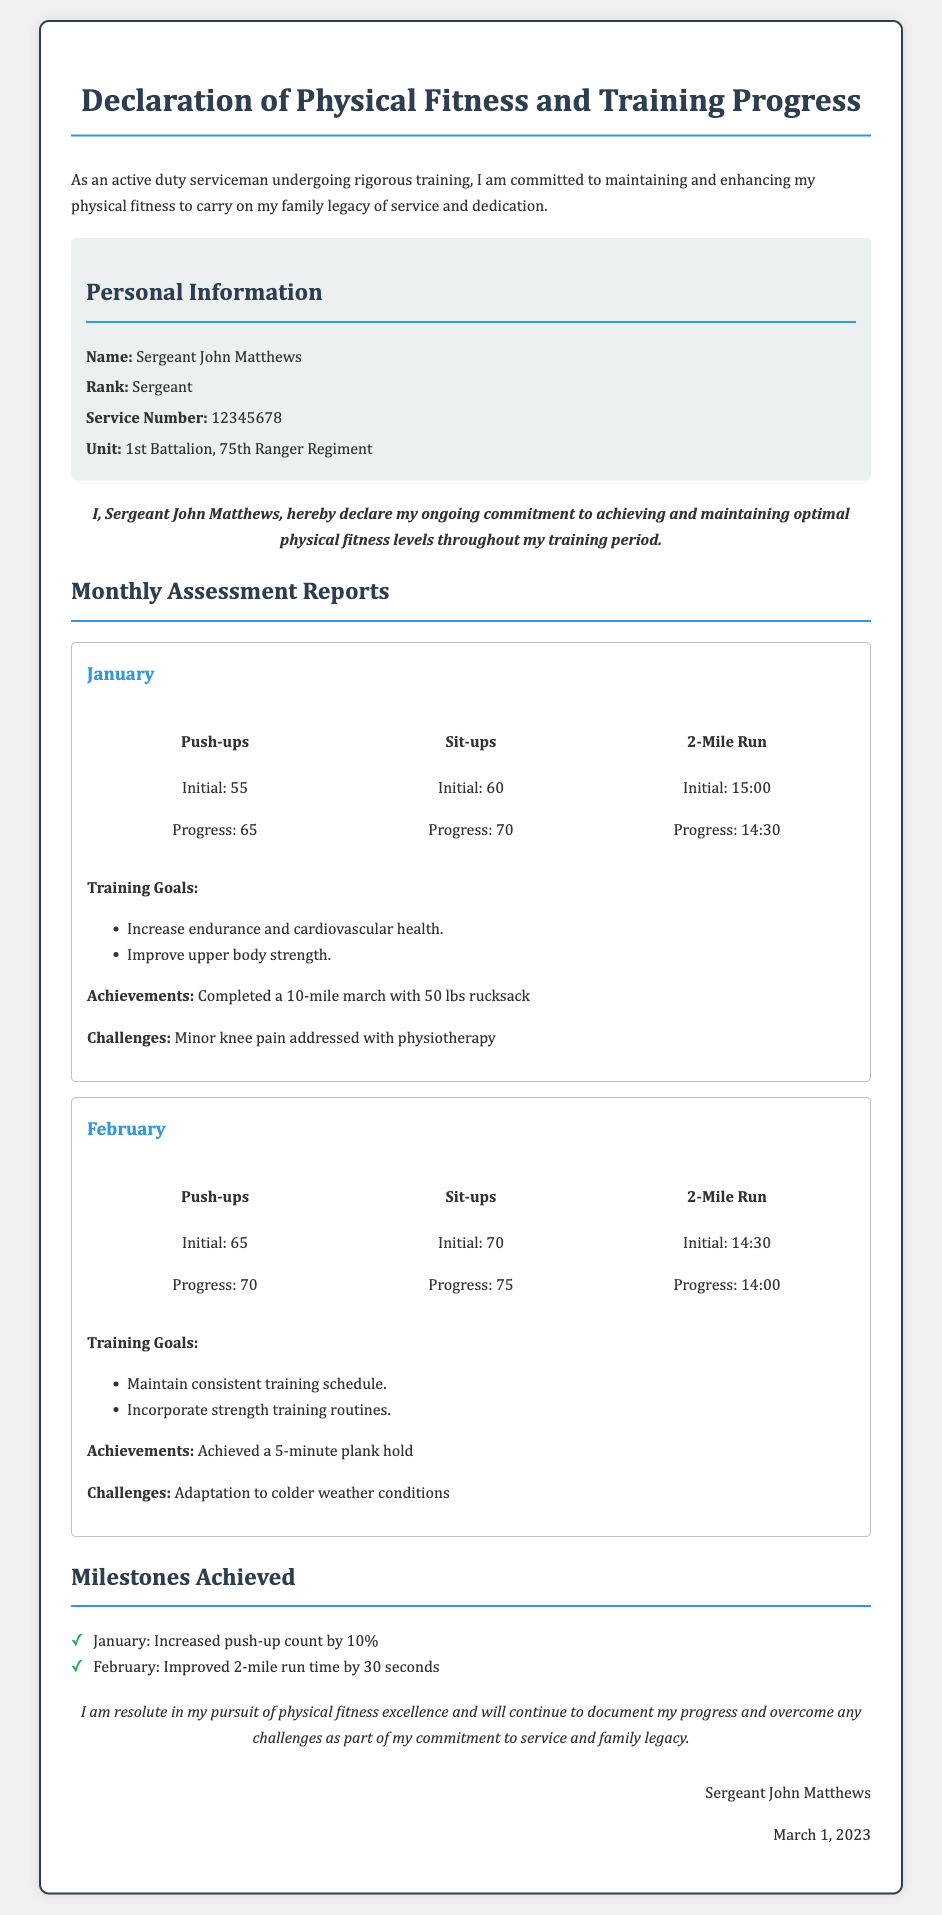What is the name of the serviceman? The document lists the name of the serviceman as Sergeant John Matthews.
Answer: Sergeant John Matthews What rank does Sergeant John Matthews hold? The document specifies the rank held by the serviceman, which is Sergeant.
Answer: Sergeant What is the initial push-up count in January? According to the January report, the initial push-up count is stated as 55.
Answer: 55 What was the progress of sit-ups in February? The report for February shows that the progress in sit-ups is 75.
Answer: 75 What milestone was achieved in January? The document states that in January, a milestone was achieved by increasing the push-up count by 10%.
Answer: Increased push-up count by 10% What training goal was set for February? One of the training goals mentioned for February was to incorporate strength training routines.
Answer: Incorporate strength training routines What was the initial 2-mile run time in January? The document indicates the initial 2-mile run time for January as 15:00.
Answer: 15:00 What challenge was faced in February? The document notes that a challenge faced in February was adaptation to colder weather conditions.
Answer: Adaptation to colder weather conditions What date was this declaration signed? The declaration was signed on March 1, 2023.
Answer: March 1, 2023 What unit does Sergeant John Matthews belong to? The document specifies that Sergeant John Matthews belongs to the 1st Battalion, 75th Ranger Regiment.
Answer: 1st Battalion, 75th Ranger Regiment 